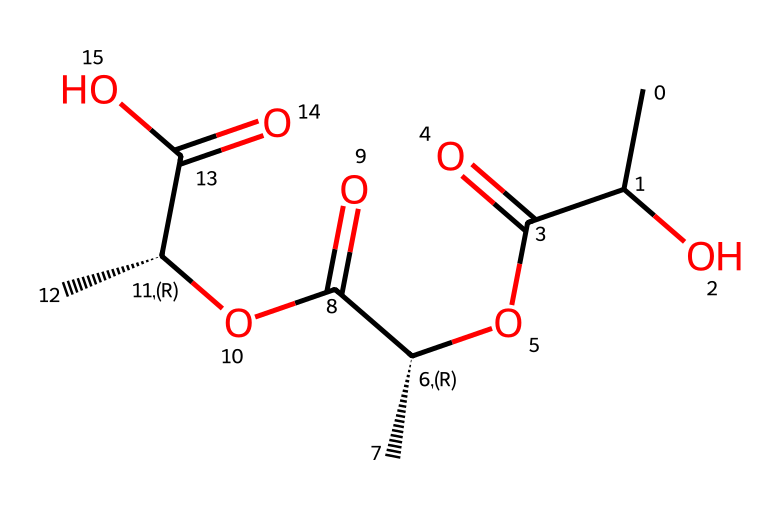What is the total number of carbon atoms in this structure? The SMILES representation shows "C" which indicates carbon atoms. By counting the carbon symbols in the SMILES, there are a total of 9 carbon atoms.
Answer: nine How many functional groups are present in this molecule? The structure contains carboxylic acid (-COOH) groups, indicated by the presence of "C(=O)O", which occurs three times. Hence, there are three functional groups.
Answer: three What type of polymer does this molecule represent? The structure resembles a biodegradable polymer due to the ester and carboxylic acid groups, commonly found in environmentally friendly materials.
Answer: biodegradable polymer What is the maximum degree of substitution on the glycerol backbone in this structure? The structure shows multiple ester groups attached to the glycerol backbone, indicating a maximum degree of substitution of three.
Answer: three Is this polymer soluble in water? This polymer, due to the presence of polar functional groups such as carboxylic acids, is expected to have good water solubility.
Answer: yes What type of reaction would be used to synthesize this polymer? The formation of this polymer likely involves esterification reactions between alcohol and carboxylic acid groups, suggesting a condensation reaction pathway.
Answer: esterification 